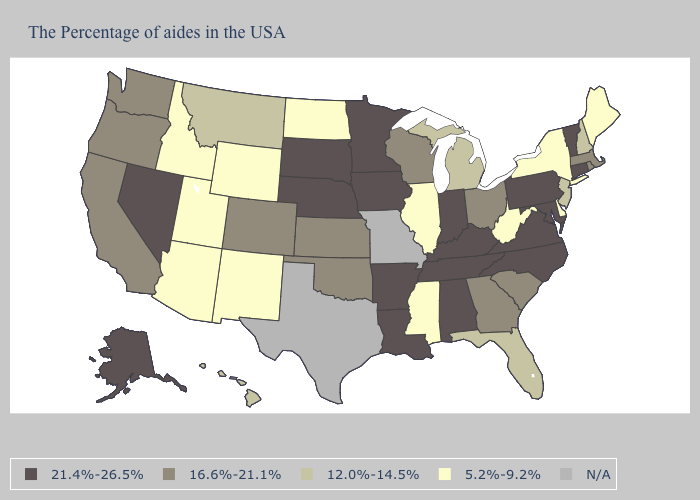Does Connecticut have the lowest value in the Northeast?
Short answer required. No. What is the value of Florida?
Concise answer only. 12.0%-14.5%. What is the value of California?
Answer briefly. 16.6%-21.1%. Among the states that border Minnesota , which have the highest value?
Give a very brief answer. Iowa, South Dakota. Among the states that border Arkansas , which have the lowest value?
Keep it brief. Mississippi. What is the value of Nevada?
Write a very short answer. 21.4%-26.5%. What is the lowest value in the USA?
Give a very brief answer. 5.2%-9.2%. What is the value of California?
Short answer required. 16.6%-21.1%. Name the states that have a value in the range 12.0%-14.5%?
Keep it brief. New Hampshire, New Jersey, Florida, Michigan, Montana, Hawaii. Name the states that have a value in the range 12.0%-14.5%?
Give a very brief answer. New Hampshire, New Jersey, Florida, Michigan, Montana, Hawaii. Among the states that border Connecticut , which have the highest value?
Give a very brief answer. Massachusetts, Rhode Island. What is the lowest value in the USA?
Answer briefly. 5.2%-9.2%. Which states have the lowest value in the USA?
Quick response, please. Maine, New York, Delaware, West Virginia, Illinois, Mississippi, North Dakota, Wyoming, New Mexico, Utah, Arizona, Idaho. Name the states that have a value in the range 16.6%-21.1%?
Give a very brief answer. Massachusetts, Rhode Island, South Carolina, Ohio, Georgia, Wisconsin, Kansas, Oklahoma, Colorado, California, Washington, Oregon. 